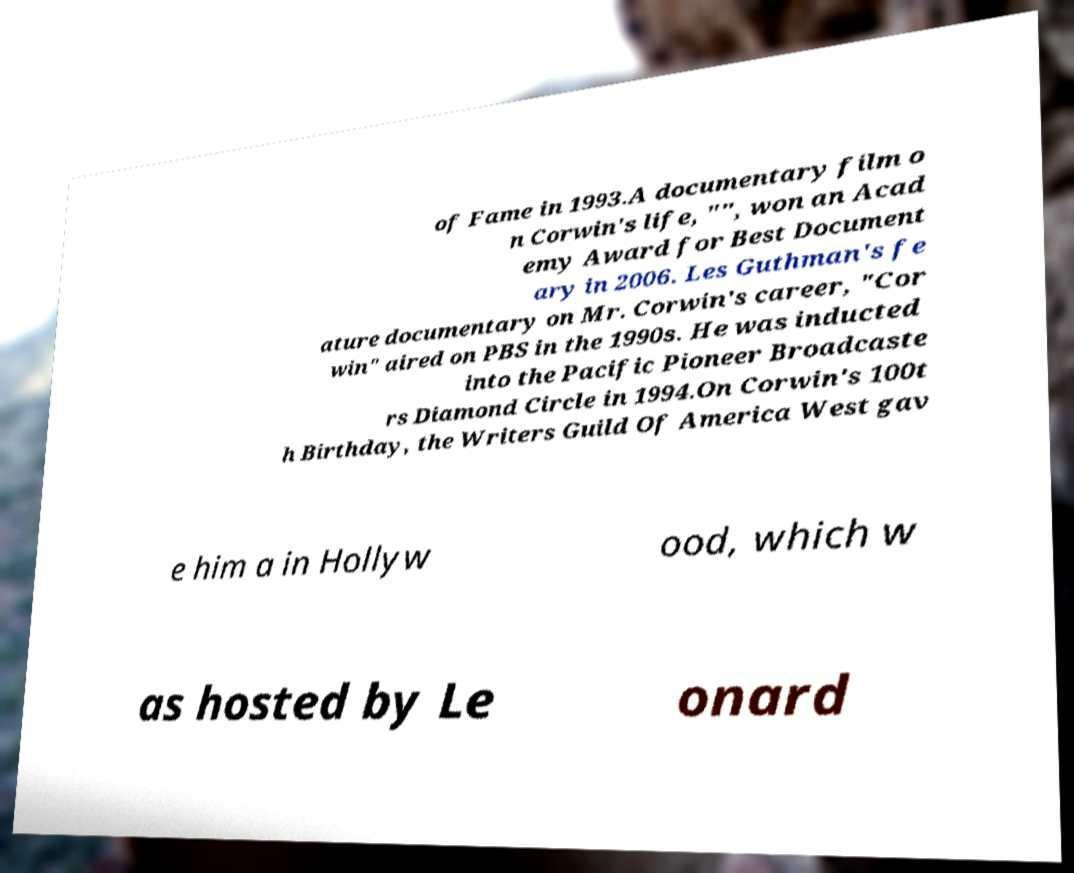Could you extract and type out the text from this image? of Fame in 1993.A documentary film o n Corwin's life, "", won an Acad emy Award for Best Document ary in 2006. Les Guthman's fe ature documentary on Mr. Corwin's career, "Cor win" aired on PBS in the 1990s. He was inducted into the Pacific Pioneer Broadcaste rs Diamond Circle in 1994.On Corwin's 100t h Birthday, the Writers Guild Of America West gav e him a in Hollyw ood, which w as hosted by Le onard 